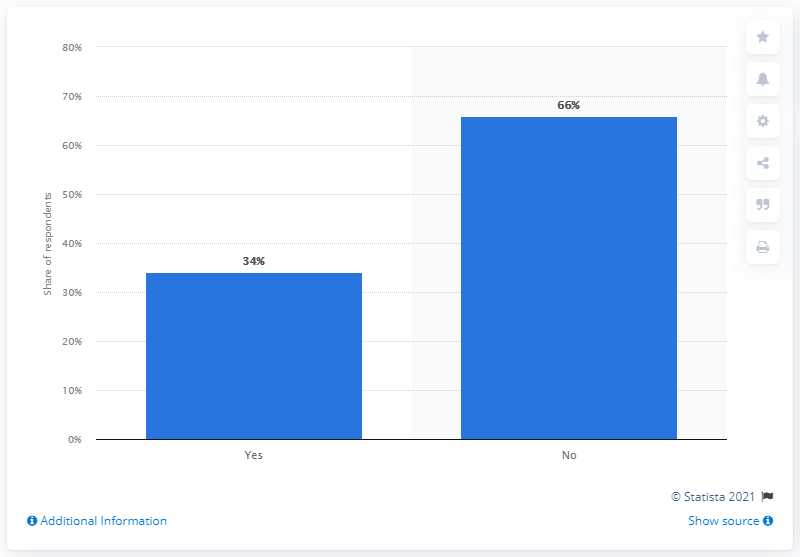Outline some significant characteristics in this image. Out of all respondents, 0.66% answered 'no'. The yes and no respondents have differences in their responses with a count of 32. 